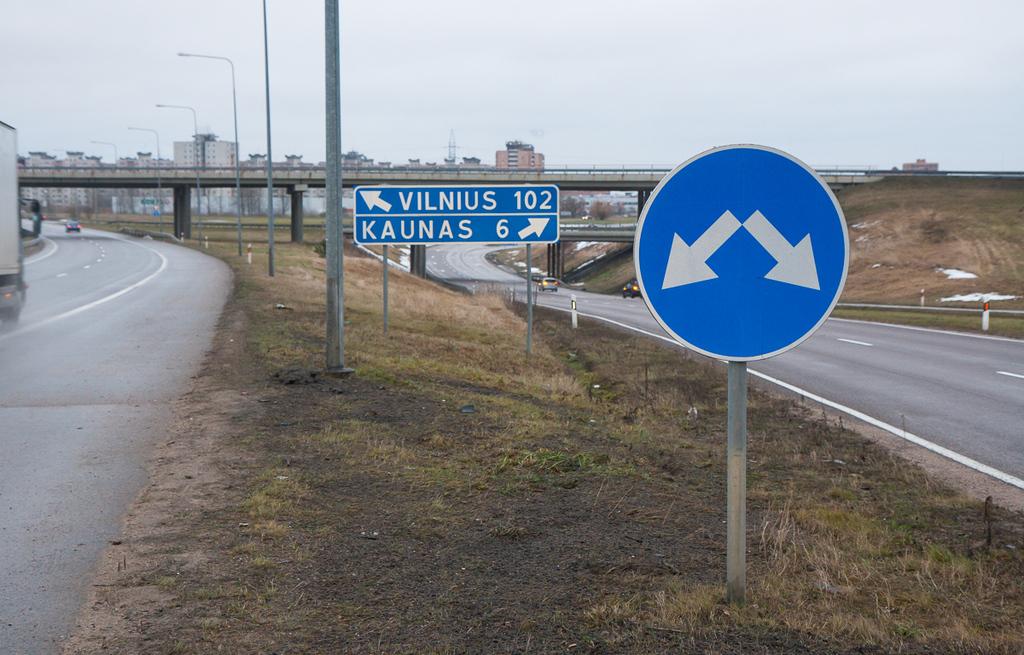What city is to the left?
Make the answer very short. Vilnius. 